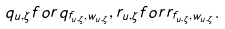<formula> <loc_0><loc_0><loc_500><loc_500>q _ { u , \zeta } f o r q _ { f _ { u , \zeta } , w _ { u , \zeta } } , r _ { u , \zeta } f o r r _ { f _ { u , \zeta } , w _ { u , \zeta } } .</formula> 